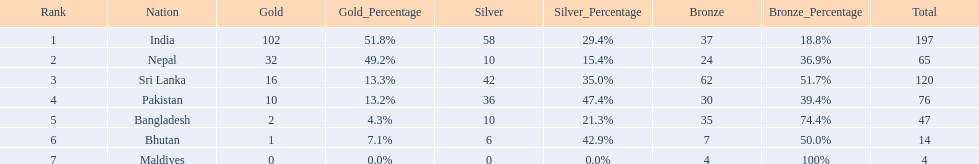Give me the full table as a dictionary. {'header': ['Rank', 'Nation', 'Gold', 'Gold_Percentage', 'Silver', 'Silver_Percentage', 'Bronze', 'Bronze_Percentage', 'Total'], 'rows': [['1', 'India', '102', '51.8%', '58', '29.4%', '37', '18.8%', '197'], ['2', 'Nepal', '32', '49.2%', '10', '15.4%', '24', '36.9%', '65'], ['3', 'Sri Lanka', '16', '13.3%', '42', '35.0%', '62', '51.7%', '120'], ['4', 'Pakistan', '10', '13.2%', '36', '47.4%', '30', '39.4%', '76'], ['5', 'Bangladesh', '2', '4.3%', '10', '21.3%', '35', '74.4%', '47'], ['6', 'Bhutan', '1', '7.1%', '6', '42.9%', '7', '50.0%', '14'], ['7', 'Maldives', '0', '0.0%', '0', '0.0%', '4', '100%', '4']]} Who has won the most bronze medals? Sri Lanka. 